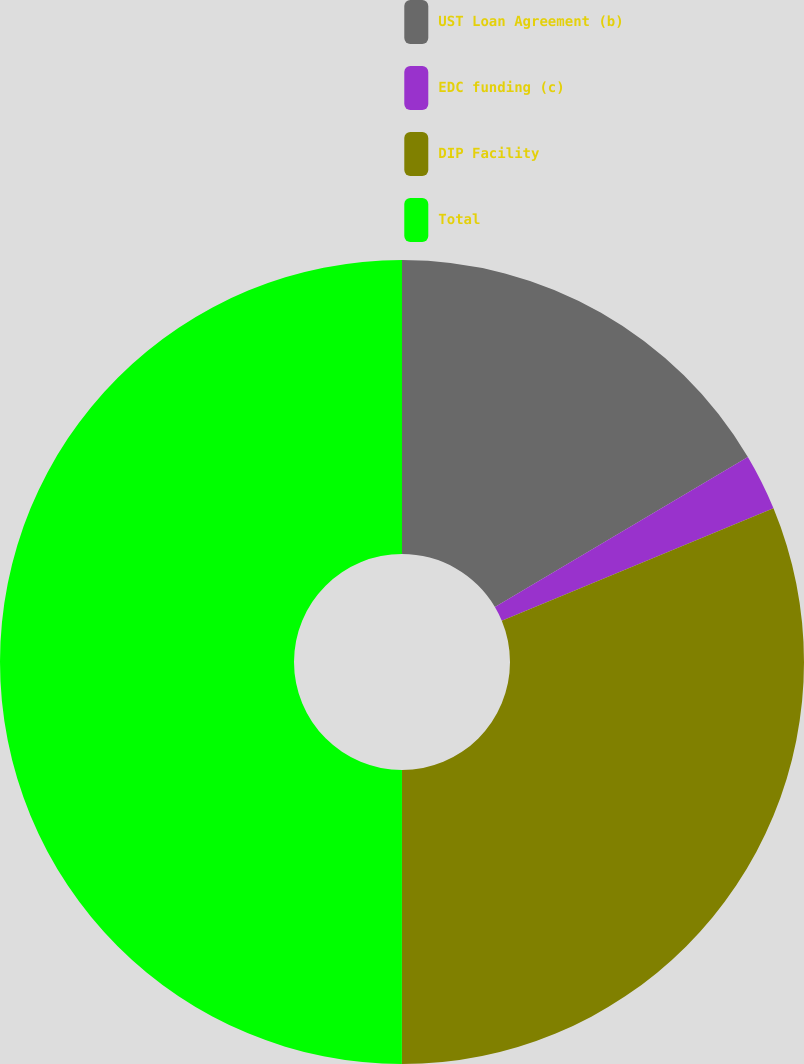Convert chart. <chart><loc_0><loc_0><loc_500><loc_500><pie_chart><fcel>UST Loan Agreement (b)<fcel>EDC funding (c)<fcel>DIP Facility<fcel>Total<nl><fcel>16.49%<fcel>2.27%<fcel>31.25%<fcel>50.0%<nl></chart> 